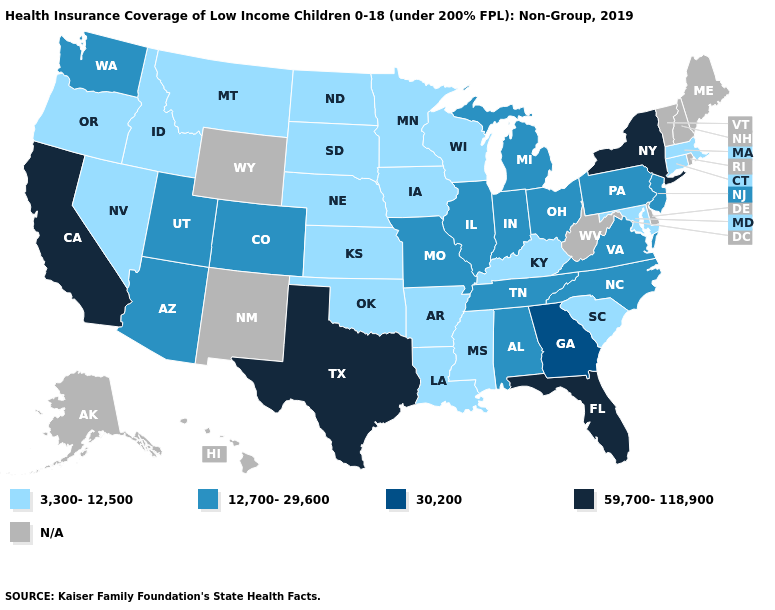What is the value of Minnesota?
Keep it brief. 3,300-12,500. Does Nevada have the lowest value in the West?
Concise answer only. Yes. What is the value of Indiana?
Write a very short answer. 12,700-29,600. Which states have the lowest value in the USA?
Be succinct. Arkansas, Connecticut, Idaho, Iowa, Kansas, Kentucky, Louisiana, Maryland, Massachusetts, Minnesota, Mississippi, Montana, Nebraska, Nevada, North Dakota, Oklahoma, Oregon, South Carolina, South Dakota, Wisconsin. What is the value of Rhode Island?
Short answer required. N/A. Name the states that have a value in the range 3,300-12,500?
Give a very brief answer. Arkansas, Connecticut, Idaho, Iowa, Kansas, Kentucky, Louisiana, Maryland, Massachusetts, Minnesota, Mississippi, Montana, Nebraska, Nevada, North Dakota, Oklahoma, Oregon, South Carolina, South Dakota, Wisconsin. Name the states that have a value in the range N/A?
Write a very short answer. Alaska, Delaware, Hawaii, Maine, New Hampshire, New Mexico, Rhode Island, Vermont, West Virginia, Wyoming. Does New York have the highest value in the Northeast?
Concise answer only. Yes. Which states have the lowest value in the Northeast?
Quick response, please. Connecticut, Massachusetts. Does Oregon have the lowest value in the West?
Be succinct. Yes. What is the value of Colorado?
Give a very brief answer. 12,700-29,600. Which states have the lowest value in the Northeast?
Write a very short answer. Connecticut, Massachusetts. 